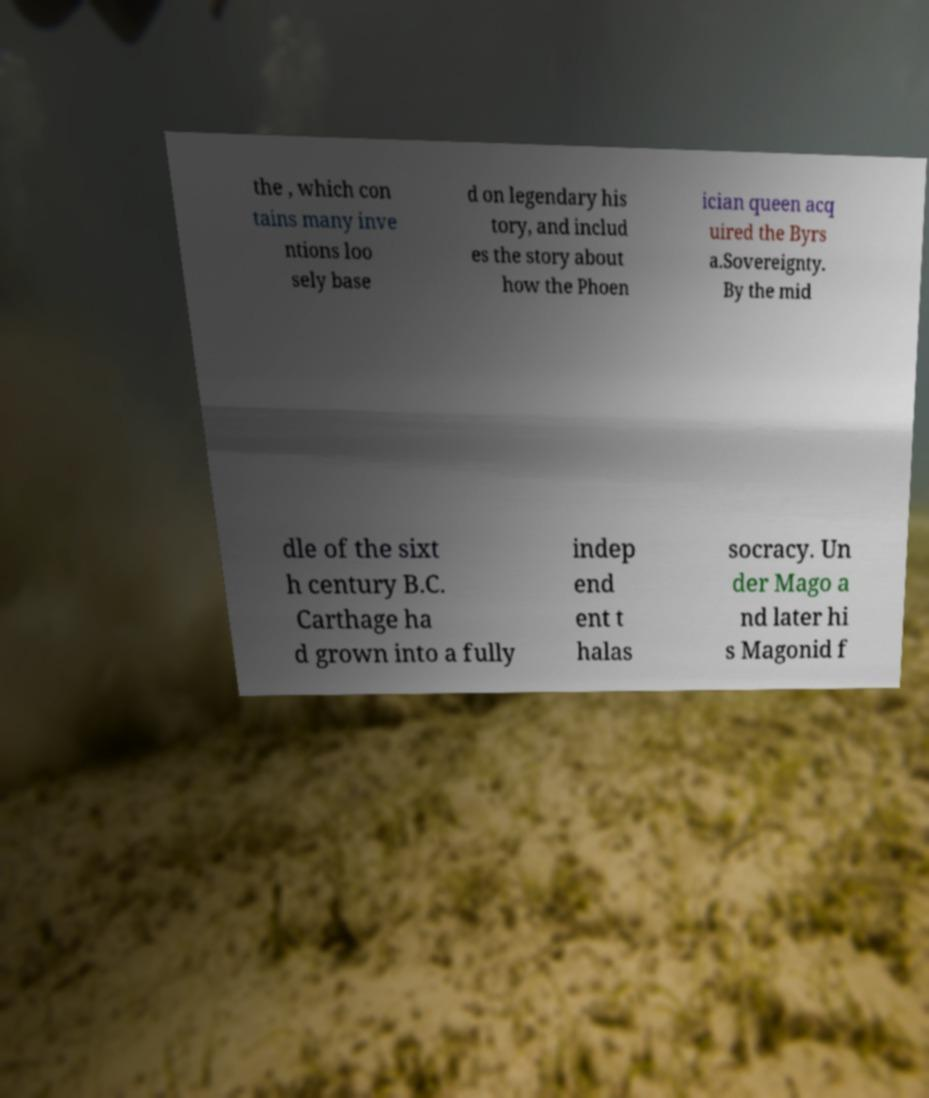For documentation purposes, I need the text within this image transcribed. Could you provide that? the , which con tains many inve ntions loo sely base d on legendary his tory, and includ es the story about how the Phoen ician queen acq uired the Byrs a.Sovereignty. By the mid dle of the sixt h century B.C. Carthage ha d grown into a fully indep end ent t halas socracy. Un der Mago a nd later hi s Magonid f 